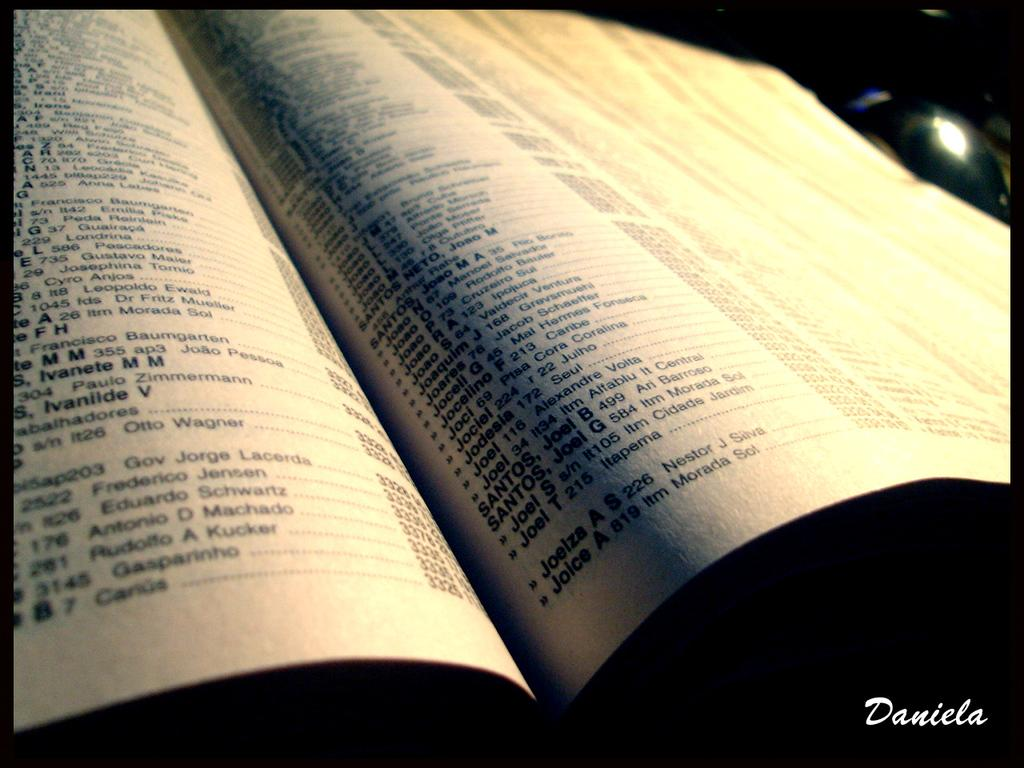<image>
Relay a brief, clear account of the picture shown. Names and addresses are listed in a booklet, the last entry on the right page is for Joice A. 